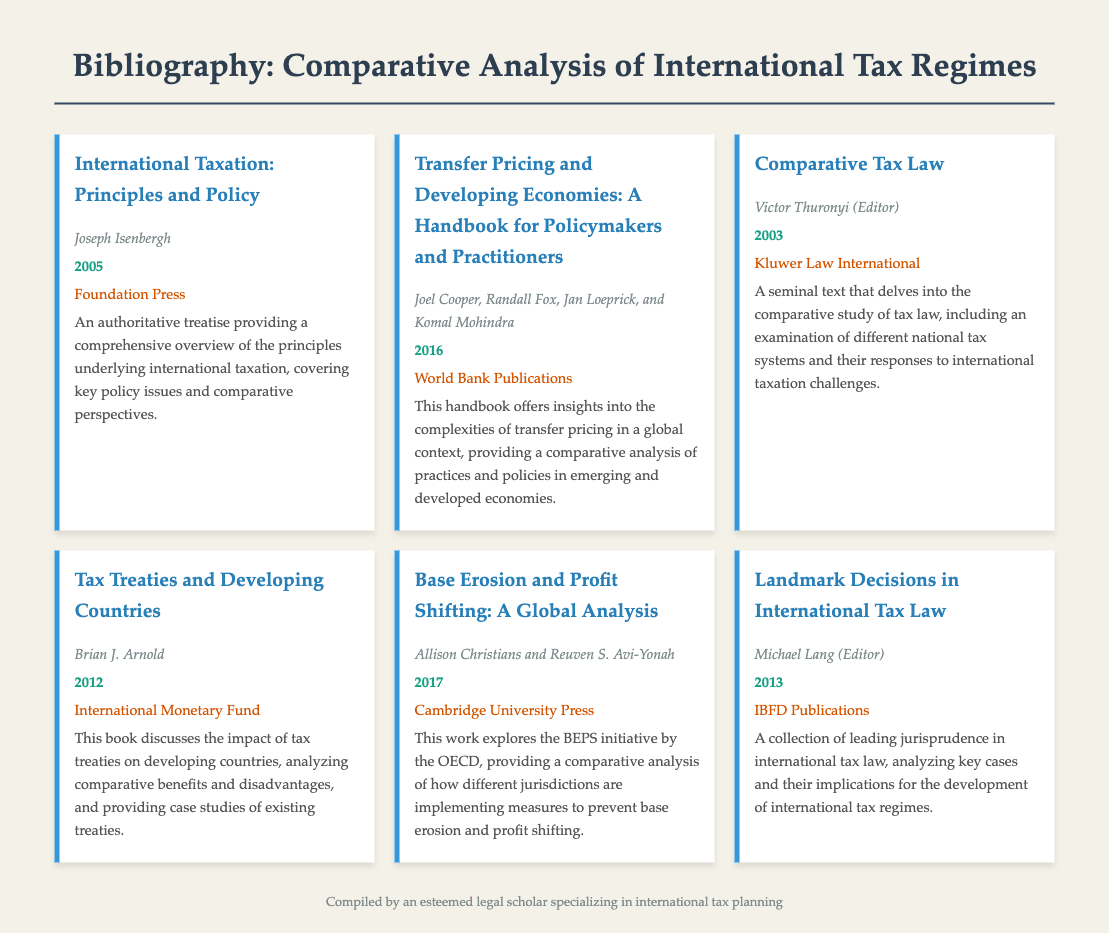What is the title of the first entry? The title of the first entry is "International Taxation: Principles and Policy."
Answer: International Taxation: Principles and Policy Who is the author of "Transfer Pricing and Developing Economies"? The author of "Transfer Pricing and Developing Economies" is Joel Cooper, Randall Fox, Jan Loeprick, and Komal Mohindra.
Answer: Joel Cooper, Randall Fox, Jan Loeprick, and Komal Mohindra What year was "Comparative Tax Law" published? "Comparative Tax Law" was published in the year 2003.
Answer: 2003 Which publication released "Tax Treaties and Developing Countries"? The International Monetary Fund released "Tax Treaties and Developing Countries."
Answer: International Monetary Fund How many authors contributed to "Base Erosion and Profit Shifting: A Global Analysis"? There are two authors who contributed to this work: Allison Christians and Reuven S. Avi-Yonah.
Answer: Two What does the description of "Landmark Decisions in International Tax Law" analyze? The description states that it analyzes key cases and their implications for the development of international tax regimes.
Answer: Key cases and their implications What is the focus of the book edited by Victor Thuronyi? The focus of the book is on the comparative study of tax law and different national tax systems.
Answer: Comparative study of tax law What is an overarching theme found in the bibliography? An overarching theme is the analysis and examination of international taxation principles and practices across various jurisdictions.
Answer: Analysis and examination of international taxation principles and practices 